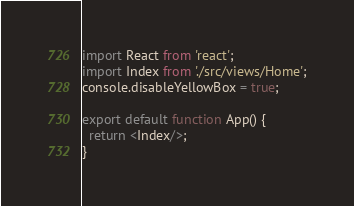Convert code to text. <code><loc_0><loc_0><loc_500><loc_500><_JavaScript_>import React from 'react';
import Index from './src/views/Home';
console.disableYellowBox = true;

export default function App() {
  return <Index/>;
}</code> 